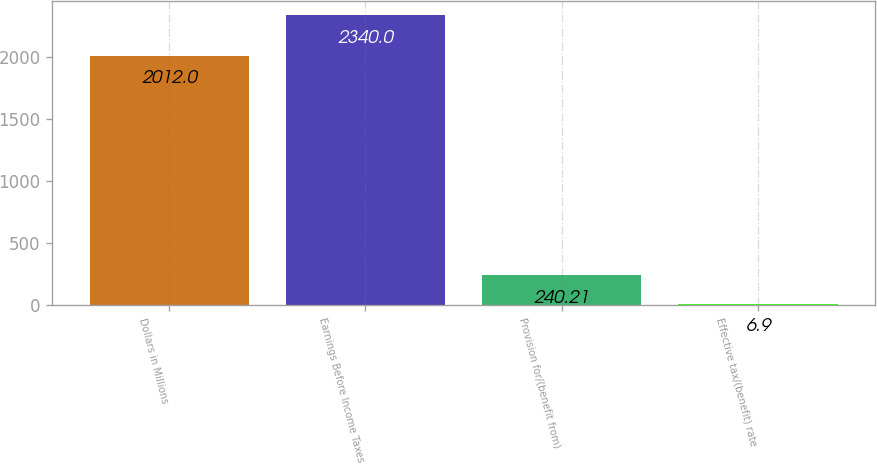Convert chart to OTSL. <chart><loc_0><loc_0><loc_500><loc_500><bar_chart><fcel>Dollars in Millions<fcel>Earnings Before Income Taxes<fcel>Provision for/(benefit from)<fcel>Effective tax/(benefit) rate<nl><fcel>2012<fcel>2340<fcel>240.21<fcel>6.9<nl></chart> 